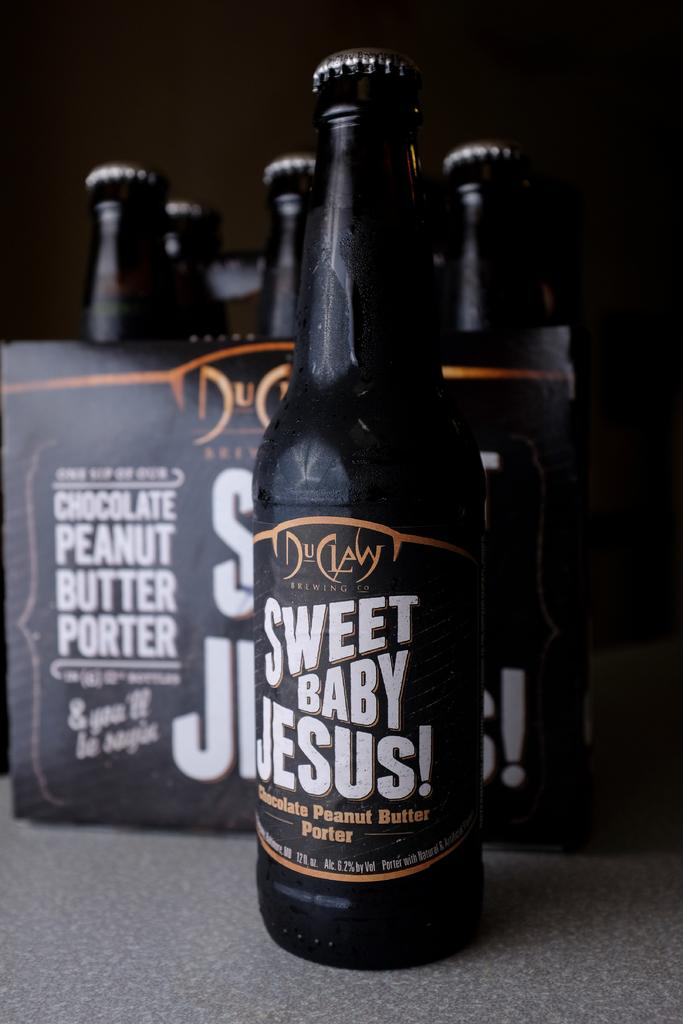Provide a one-sentence caption for the provided image. a Sweet Baby Jesus porter next to a six pack of the same. 